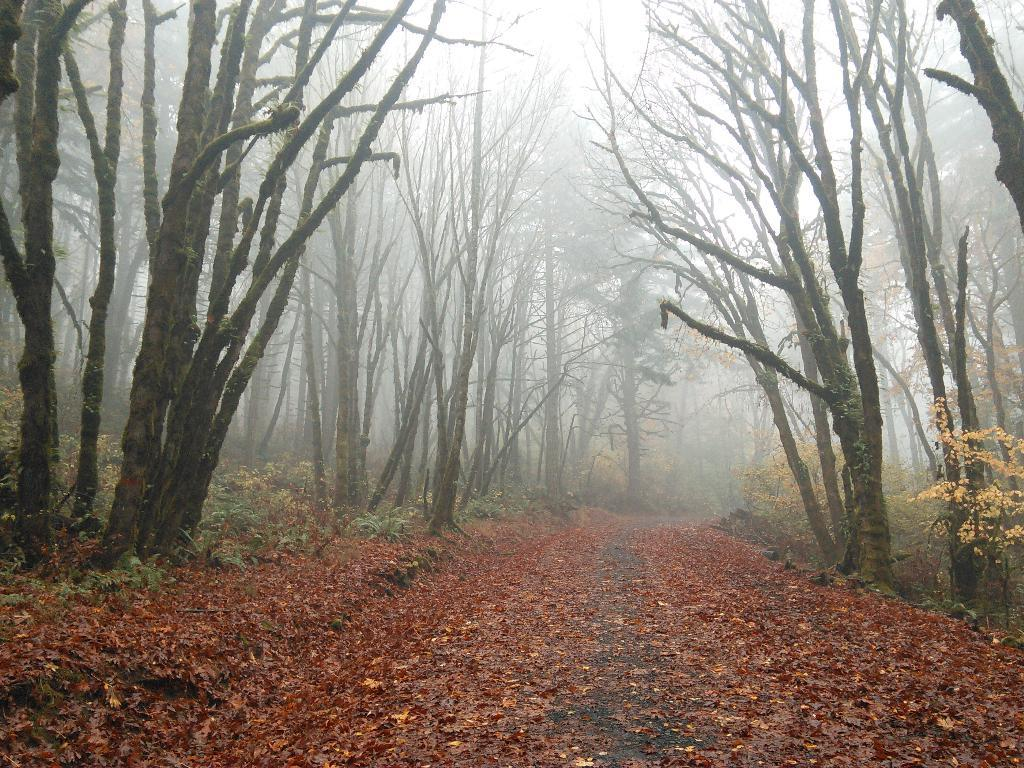What is the main feature in the center of the image? There is a road in the center of the image. What can be seen on the road? Dried leaves are present on the road. What is the condition of the trees on both sides of the image? There are dried trees on both sides of the image. What is the chance of seeing someone smiling with a tooth in the image? There is no person present in the image, so it is not possible to determine the chance of seeing someone smiling with a tooth. 